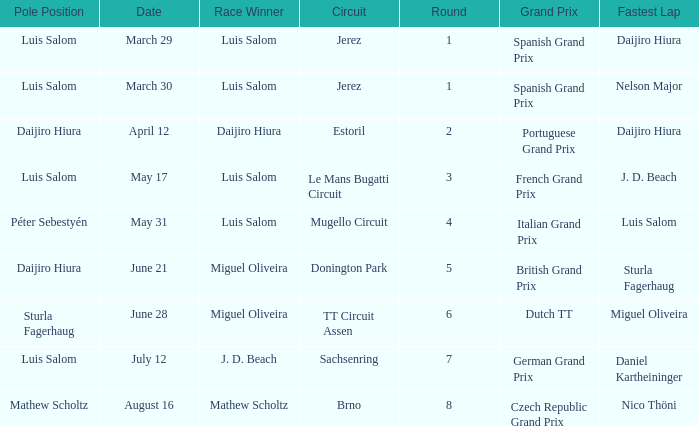Who had the fastest lap in the Dutch TT Grand Prix?  Miguel Oliveira. 